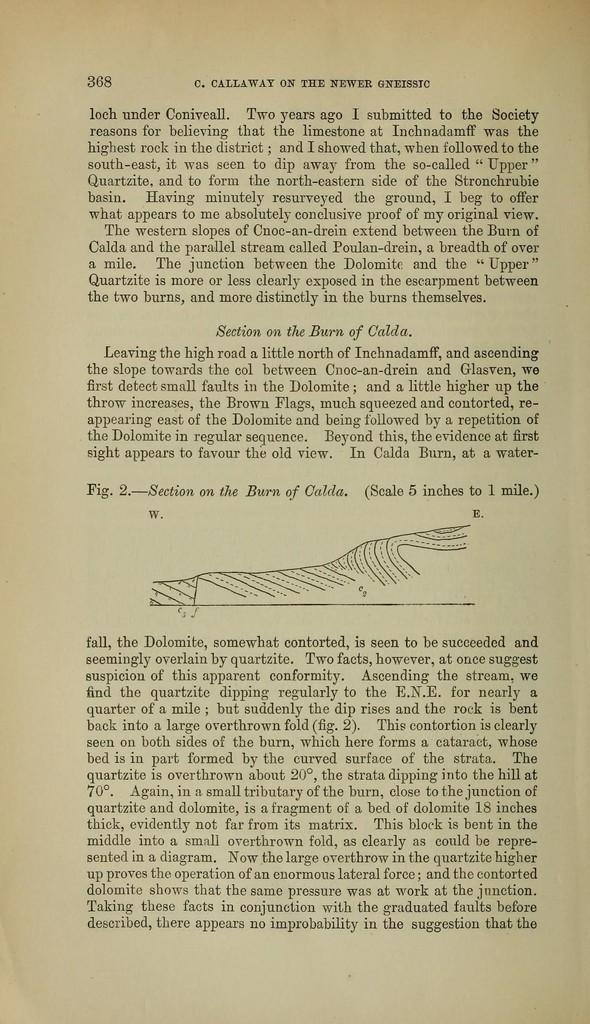<image>
Relay a brief, clear account of the picture shown. C. Callaway on the newer Gneissic book page 368. 